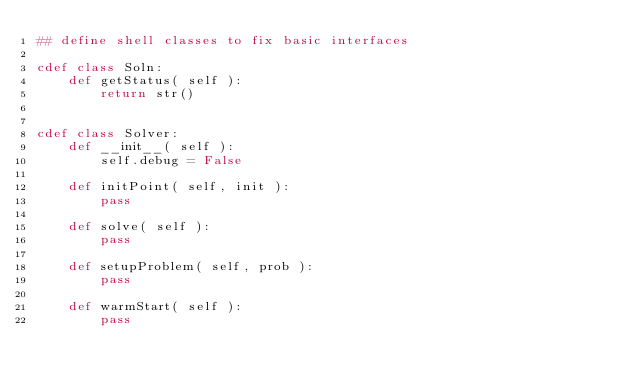Convert code to text. <code><loc_0><loc_0><loc_500><loc_500><_Cython_>## define shell classes to fix basic interfaces

cdef class Soln:
    def getStatus( self ):
        return str()


cdef class Solver:
    def __init__( self ):
        self.debug = False

    def initPoint( self, init ):
        pass

    def solve( self ):
        pass

    def setupProblem( self, prob ):
        pass

    def warmStart( self ):
        pass
</code> 